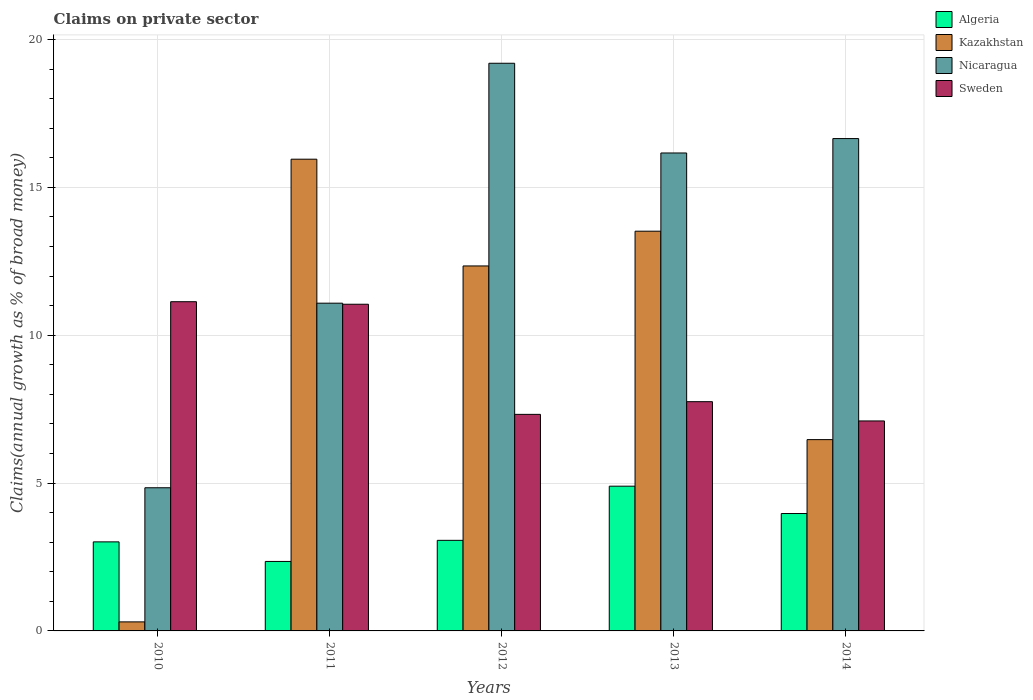How many groups of bars are there?
Make the answer very short. 5. Are the number of bars per tick equal to the number of legend labels?
Ensure brevity in your answer.  Yes. Are the number of bars on each tick of the X-axis equal?
Your response must be concise. Yes. How many bars are there on the 3rd tick from the left?
Your response must be concise. 4. What is the label of the 4th group of bars from the left?
Ensure brevity in your answer.  2013. In how many cases, is the number of bars for a given year not equal to the number of legend labels?
Your answer should be compact. 0. What is the percentage of broad money claimed on private sector in Sweden in 2010?
Offer a terse response. 11.13. Across all years, what is the maximum percentage of broad money claimed on private sector in Kazakhstan?
Provide a succinct answer. 15.95. Across all years, what is the minimum percentage of broad money claimed on private sector in Kazakhstan?
Give a very brief answer. 0.31. In which year was the percentage of broad money claimed on private sector in Algeria maximum?
Give a very brief answer. 2013. In which year was the percentage of broad money claimed on private sector in Algeria minimum?
Offer a terse response. 2011. What is the total percentage of broad money claimed on private sector in Sweden in the graph?
Your response must be concise. 44.35. What is the difference between the percentage of broad money claimed on private sector in Sweden in 2012 and that in 2014?
Your answer should be compact. 0.22. What is the difference between the percentage of broad money claimed on private sector in Algeria in 2010 and the percentage of broad money claimed on private sector in Nicaragua in 2014?
Your answer should be very brief. -13.64. What is the average percentage of broad money claimed on private sector in Sweden per year?
Keep it short and to the point. 8.87. In the year 2013, what is the difference between the percentage of broad money claimed on private sector in Algeria and percentage of broad money claimed on private sector in Nicaragua?
Your answer should be compact. -11.27. In how many years, is the percentage of broad money claimed on private sector in Nicaragua greater than 14 %?
Provide a succinct answer. 3. What is the ratio of the percentage of broad money claimed on private sector in Kazakhstan in 2012 to that in 2014?
Ensure brevity in your answer.  1.91. Is the percentage of broad money claimed on private sector in Sweden in 2010 less than that in 2013?
Your response must be concise. No. What is the difference between the highest and the second highest percentage of broad money claimed on private sector in Kazakhstan?
Offer a terse response. 2.43. What is the difference between the highest and the lowest percentage of broad money claimed on private sector in Sweden?
Your answer should be compact. 4.03. In how many years, is the percentage of broad money claimed on private sector in Kazakhstan greater than the average percentage of broad money claimed on private sector in Kazakhstan taken over all years?
Provide a succinct answer. 3. Is the sum of the percentage of broad money claimed on private sector in Sweden in 2011 and 2014 greater than the maximum percentage of broad money claimed on private sector in Algeria across all years?
Provide a short and direct response. Yes. Is it the case that in every year, the sum of the percentage of broad money claimed on private sector in Kazakhstan and percentage of broad money claimed on private sector in Sweden is greater than the sum of percentage of broad money claimed on private sector in Algeria and percentage of broad money claimed on private sector in Nicaragua?
Offer a terse response. No. What does the 3rd bar from the right in 2010 represents?
Offer a very short reply. Kazakhstan. Is it the case that in every year, the sum of the percentage of broad money claimed on private sector in Nicaragua and percentage of broad money claimed on private sector in Kazakhstan is greater than the percentage of broad money claimed on private sector in Sweden?
Provide a succinct answer. No. How many bars are there?
Give a very brief answer. 20. Are all the bars in the graph horizontal?
Keep it short and to the point. No. How are the legend labels stacked?
Offer a very short reply. Vertical. What is the title of the graph?
Offer a terse response. Claims on private sector. Does "Hong Kong" appear as one of the legend labels in the graph?
Ensure brevity in your answer.  No. What is the label or title of the Y-axis?
Give a very brief answer. Claims(annual growth as % of broad money). What is the Claims(annual growth as % of broad money) in Algeria in 2010?
Give a very brief answer. 3.01. What is the Claims(annual growth as % of broad money) of Kazakhstan in 2010?
Offer a very short reply. 0.31. What is the Claims(annual growth as % of broad money) of Nicaragua in 2010?
Offer a terse response. 4.84. What is the Claims(annual growth as % of broad money) of Sweden in 2010?
Keep it short and to the point. 11.13. What is the Claims(annual growth as % of broad money) of Algeria in 2011?
Your answer should be very brief. 2.35. What is the Claims(annual growth as % of broad money) in Kazakhstan in 2011?
Provide a short and direct response. 15.95. What is the Claims(annual growth as % of broad money) of Nicaragua in 2011?
Offer a very short reply. 11.08. What is the Claims(annual growth as % of broad money) of Sweden in 2011?
Your answer should be very brief. 11.05. What is the Claims(annual growth as % of broad money) of Algeria in 2012?
Your response must be concise. 3.06. What is the Claims(annual growth as % of broad money) in Kazakhstan in 2012?
Your response must be concise. 12.34. What is the Claims(annual growth as % of broad money) of Nicaragua in 2012?
Provide a succinct answer. 19.2. What is the Claims(annual growth as % of broad money) in Sweden in 2012?
Provide a short and direct response. 7.32. What is the Claims(annual growth as % of broad money) in Algeria in 2013?
Provide a short and direct response. 4.89. What is the Claims(annual growth as % of broad money) in Kazakhstan in 2013?
Keep it short and to the point. 13.52. What is the Claims(annual growth as % of broad money) of Nicaragua in 2013?
Offer a very short reply. 16.16. What is the Claims(annual growth as % of broad money) in Sweden in 2013?
Ensure brevity in your answer.  7.75. What is the Claims(annual growth as % of broad money) of Algeria in 2014?
Your answer should be very brief. 3.97. What is the Claims(annual growth as % of broad money) in Kazakhstan in 2014?
Your answer should be very brief. 6.47. What is the Claims(annual growth as % of broad money) in Nicaragua in 2014?
Your response must be concise. 16.65. What is the Claims(annual growth as % of broad money) in Sweden in 2014?
Offer a very short reply. 7.1. Across all years, what is the maximum Claims(annual growth as % of broad money) in Algeria?
Keep it short and to the point. 4.89. Across all years, what is the maximum Claims(annual growth as % of broad money) in Kazakhstan?
Provide a succinct answer. 15.95. Across all years, what is the maximum Claims(annual growth as % of broad money) in Nicaragua?
Provide a short and direct response. 19.2. Across all years, what is the maximum Claims(annual growth as % of broad money) of Sweden?
Offer a very short reply. 11.13. Across all years, what is the minimum Claims(annual growth as % of broad money) in Algeria?
Your response must be concise. 2.35. Across all years, what is the minimum Claims(annual growth as % of broad money) in Kazakhstan?
Your answer should be compact. 0.31. Across all years, what is the minimum Claims(annual growth as % of broad money) of Nicaragua?
Provide a succinct answer. 4.84. Across all years, what is the minimum Claims(annual growth as % of broad money) of Sweden?
Give a very brief answer. 7.1. What is the total Claims(annual growth as % of broad money) of Algeria in the graph?
Give a very brief answer. 17.29. What is the total Claims(annual growth as % of broad money) of Kazakhstan in the graph?
Offer a terse response. 48.58. What is the total Claims(annual growth as % of broad money) of Nicaragua in the graph?
Your answer should be compact. 67.93. What is the total Claims(annual growth as % of broad money) in Sweden in the graph?
Offer a terse response. 44.35. What is the difference between the Claims(annual growth as % of broad money) in Algeria in 2010 and that in 2011?
Ensure brevity in your answer.  0.66. What is the difference between the Claims(annual growth as % of broad money) in Kazakhstan in 2010 and that in 2011?
Keep it short and to the point. -15.65. What is the difference between the Claims(annual growth as % of broad money) in Nicaragua in 2010 and that in 2011?
Your response must be concise. -6.24. What is the difference between the Claims(annual growth as % of broad money) of Sweden in 2010 and that in 2011?
Your answer should be compact. 0.09. What is the difference between the Claims(annual growth as % of broad money) of Algeria in 2010 and that in 2012?
Provide a short and direct response. -0.05. What is the difference between the Claims(annual growth as % of broad money) of Kazakhstan in 2010 and that in 2012?
Keep it short and to the point. -12.04. What is the difference between the Claims(annual growth as % of broad money) in Nicaragua in 2010 and that in 2012?
Your answer should be compact. -14.35. What is the difference between the Claims(annual growth as % of broad money) of Sweden in 2010 and that in 2012?
Make the answer very short. 3.81. What is the difference between the Claims(annual growth as % of broad money) in Algeria in 2010 and that in 2013?
Your answer should be compact. -1.88. What is the difference between the Claims(annual growth as % of broad money) in Kazakhstan in 2010 and that in 2013?
Provide a short and direct response. -13.21. What is the difference between the Claims(annual growth as % of broad money) in Nicaragua in 2010 and that in 2013?
Your answer should be compact. -11.32. What is the difference between the Claims(annual growth as % of broad money) of Sweden in 2010 and that in 2013?
Provide a succinct answer. 3.38. What is the difference between the Claims(annual growth as % of broad money) in Algeria in 2010 and that in 2014?
Keep it short and to the point. -0.96. What is the difference between the Claims(annual growth as % of broad money) of Kazakhstan in 2010 and that in 2014?
Offer a terse response. -6.16. What is the difference between the Claims(annual growth as % of broad money) in Nicaragua in 2010 and that in 2014?
Provide a succinct answer. -11.81. What is the difference between the Claims(annual growth as % of broad money) of Sweden in 2010 and that in 2014?
Your answer should be compact. 4.03. What is the difference between the Claims(annual growth as % of broad money) in Algeria in 2011 and that in 2012?
Your answer should be compact. -0.71. What is the difference between the Claims(annual growth as % of broad money) of Kazakhstan in 2011 and that in 2012?
Provide a short and direct response. 3.61. What is the difference between the Claims(annual growth as % of broad money) of Nicaragua in 2011 and that in 2012?
Keep it short and to the point. -8.11. What is the difference between the Claims(annual growth as % of broad money) in Sweden in 2011 and that in 2012?
Offer a terse response. 3.72. What is the difference between the Claims(annual growth as % of broad money) of Algeria in 2011 and that in 2013?
Give a very brief answer. -2.55. What is the difference between the Claims(annual growth as % of broad money) of Kazakhstan in 2011 and that in 2013?
Give a very brief answer. 2.43. What is the difference between the Claims(annual growth as % of broad money) of Nicaragua in 2011 and that in 2013?
Offer a very short reply. -5.08. What is the difference between the Claims(annual growth as % of broad money) of Sweden in 2011 and that in 2013?
Your answer should be very brief. 3.29. What is the difference between the Claims(annual growth as % of broad money) of Algeria in 2011 and that in 2014?
Provide a short and direct response. -1.62. What is the difference between the Claims(annual growth as % of broad money) in Kazakhstan in 2011 and that in 2014?
Ensure brevity in your answer.  9.48. What is the difference between the Claims(annual growth as % of broad money) of Nicaragua in 2011 and that in 2014?
Ensure brevity in your answer.  -5.57. What is the difference between the Claims(annual growth as % of broad money) in Sweden in 2011 and that in 2014?
Give a very brief answer. 3.95. What is the difference between the Claims(annual growth as % of broad money) in Algeria in 2012 and that in 2013?
Provide a succinct answer. -1.83. What is the difference between the Claims(annual growth as % of broad money) in Kazakhstan in 2012 and that in 2013?
Your answer should be compact. -1.17. What is the difference between the Claims(annual growth as % of broad money) in Nicaragua in 2012 and that in 2013?
Provide a succinct answer. 3.03. What is the difference between the Claims(annual growth as % of broad money) of Sweden in 2012 and that in 2013?
Provide a short and direct response. -0.43. What is the difference between the Claims(annual growth as % of broad money) in Algeria in 2012 and that in 2014?
Give a very brief answer. -0.91. What is the difference between the Claims(annual growth as % of broad money) in Kazakhstan in 2012 and that in 2014?
Your answer should be compact. 5.87. What is the difference between the Claims(annual growth as % of broad money) of Nicaragua in 2012 and that in 2014?
Your answer should be very brief. 2.55. What is the difference between the Claims(annual growth as % of broad money) in Sweden in 2012 and that in 2014?
Make the answer very short. 0.22. What is the difference between the Claims(annual growth as % of broad money) in Algeria in 2013 and that in 2014?
Offer a terse response. 0.92. What is the difference between the Claims(annual growth as % of broad money) of Kazakhstan in 2013 and that in 2014?
Offer a very short reply. 7.05. What is the difference between the Claims(annual growth as % of broad money) in Nicaragua in 2013 and that in 2014?
Make the answer very short. -0.49. What is the difference between the Claims(annual growth as % of broad money) of Sweden in 2013 and that in 2014?
Your response must be concise. 0.65. What is the difference between the Claims(annual growth as % of broad money) in Algeria in 2010 and the Claims(annual growth as % of broad money) in Kazakhstan in 2011?
Your answer should be compact. -12.94. What is the difference between the Claims(annual growth as % of broad money) of Algeria in 2010 and the Claims(annual growth as % of broad money) of Nicaragua in 2011?
Your answer should be very brief. -8.07. What is the difference between the Claims(annual growth as % of broad money) in Algeria in 2010 and the Claims(annual growth as % of broad money) in Sweden in 2011?
Make the answer very short. -8.04. What is the difference between the Claims(annual growth as % of broad money) of Kazakhstan in 2010 and the Claims(annual growth as % of broad money) of Nicaragua in 2011?
Ensure brevity in your answer.  -10.78. What is the difference between the Claims(annual growth as % of broad money) of Kazakhstan in 2010 and the Claims(annual growth as % of broad money) of Sweden in 2011?
Your answer should be compact. -10.74. What is the difference between the Claims(annual growth as % of broad money) in Nicaragua in 2010 and the Claims(annual growth as % of broad money) in Sweden in 2011?
Give a very brief answer. -6.21. What is the difference between the Claims(annual growth as % of broad money) in Algeria in 2010 and the Claims(annual growth as % of broad money) in Kazakhstan in 2012?
Your response must be concise. -9.33. What is the difference between the Claims(annual growth as % of broad money) in Algeria in 2010 and the Claims(annual growth as % of broad money) in Nicaragua in 2012?
Give a very brief answer. -16.18. What is the difference between the Claims(annual growth as % of broad money) of Algeria in 2010 and the Claims(annual growth as % of broad money) of Sweden in 2012?
Your answer should be compact. -4.31. What is the difference between the Claims(annual growth as % of broad money) of Kazakhstan in 2010 and the Claims(annual growth as % of broad money) of Nicaragua in 2012?
Make the answer very short. -18.89. What is the difference between the Claims(annual growth as % of broad money) of Kazakhstan in 2010 and the Claims(annual growth as % of broad money) of Sweden in 2012?
Provide a succinct answer. -7.02. What is the difference between the Claims(annual growth as % of broad money) in Nicaragua in 2010 and the Claims(annual growth as % of broad money) in Sweden in 2012?
Provide a short and direct response. -2.48. What is the difference between the Claims(annual growth as % of broad money) in Algeria in 2010 and the Claims(annual growth as % of broad money) in Kazakhstan in 2013?
Offer a very short reply. -10.51. What is the difference between the Claims(annual growth as % of broad money) in Algeria in 2010 and the Claims(annual growth as % of broad money) in Nicaragua in 2013?
Your answer should be compact. -13.15. What is the difference between the Claims(annual growth as % of broad money) in Algeria in 2010 and the Claims(annual growth as % of broad money) in Sweden in 2013?
Provide a succinct answer. -4.74. What is the difference between the Claims(annual growth as % of broad money) of Kazakhstan in 2010 and the Claims(annual growth as % of broad money) of Nicaragua in 2013?
Your answer should be compact. -15.86. What is the difference between the Claims(annual growth as % of broad money) of Kazakhstan in 2010 and the Claims(annual growth as % of broad money) of Sweden in 2013?
Make the answer very short. -7.45. What is the difference between the Claims(annual growth as % of broad money) of Nicaragua in 2010 and the Claims(annual growth as % of broad money) of Sweden in 2013?
Your answer should be very brief. -2.91. What is the difference between the Claims(annual growth as % of broad money) of Algeria in 2010 and the Claims(annual growth as % of broad money) of Kazakhstan in 2014?
Your answer should be compact. -3.46. What is the difference between the Claims(annual growth as % of broad money) of Algeria in 2010 and the Claims(annual growth as % of broad money) of Nicaragua in 2014?
Make the answer very short. -13.64. What is the difference between the Claims(annual growth as % of broad money) in Algeria in 2010 and the Claims(annual growth as % of broad money) in Sweden in 2014?
Your answer should be very brief. -4.09. What is the difference between the Claims(annual growth as % of broad money) in Kazakhstan in 2010 and the Claims(annual growth as % of broad money) in Nicaragua in 2014?
Make the answer very short. -16.34. What is the difference between the Claims(annual growth as % of broad money) of Kazakhstan in 2010 and the Claims(annual growth as % of broad money) of Sweden in 2014?
Keep it short and to the point. -6.79. What is the difference between the Claims(annual growth as % of broad money) of Nicaragua in 2010 and the Claims(annual growth as % of broad money) of Sweden in 2014?
Keep it short and to the point. -2.26. What is the difference between the Claims(annual growth as % of broad money) in Algeria in 2011 and the Claims(annual growth as % of broad money) in Kazakhstan in 2012?
Offer a terse response. -9.99. What is the difference between the Claims(annual growth as % of broad money) in Algeria in 2011 and the Claims(annual growth as % of broad money) in Nicaragua in 2012?
Provide a short and direct response. -16.85. What is the difference between the Claims(annual growth as % of broad money) of Algeria in 2011 and the Claims(annual growth as % of broad money) of Sweden in 2012?
Your answer should be very brief. -4.97. What is the difference between the Claims(annual growth as % of broad money) in Kazakhstan in 2011 and the Claims(annual growth as % of broad money) in Nicaragua in 2012?
Give a very brief answer. -3.24. What is the difference between the Claims(annual growth as % of broad money) in Kazakhstan in 2011 and the Claims(annual growth as % of broad money) in Sweden in 2012?
Ensure brevity in your answer.  8.63. What is the difference between the Claims(annual growth as % of broad money) in Nicaragua in 2011 and the Claims(annual growth as % of broad money) in Sweden in 2012?
Keep it short and to the point. 3.76. What is the difference between the Claims(annual growth as % of broad money) of Algeria in 2011 and the Claims(annual growth as % of broad money) of Kazakhstan in 2013?
Give a very brief answer. -11.17. What is the difference between the Claims(annual growth as % of broad money) of Algeria in 2011 and the Claims(annual growth as % of broad money) of Nicaragua in 2013?
Offer a terse response. -13.81. What is the difference between the Claims(annual growth as % of broad money) of Algeria in 2011 and the Claims(annual growth as % of broad money) of Sweden in 2013?
Your response must be concise. -5.4. What is the difference between the Claims(annual growth as % of broad money) in Kazakhstan in 2011 and the Claims(annual growth as % of broad money) in Nicaragua in 2013?
Make the answer very short. -0.21. What is the difference between the Claims(annual growth as % of broad money) of Kazakhstan in 2011 and the Claims(annual growth as % of broad money) of Sweden in 2013?
Make the answer very short. 8.2. What is the difference between the Claims(annual growth as % of broad money) of Nicaragua in 2011 and the Claims(annual growth as % of broad money) of Sweden in 2013?
Keep it short and to the point. 3.33. What is the difference between the Claims(annual growth as % of broad money) in Algeria in 2011 and the Claims(annual growth as % of broad money) in Kazakhstan in 2014?
Provide a succinct answer. -4.12. What is the difference between the Claims(annual growth as % of broad money) in Algeria in 2011 and the Claims(annual growth as % of broad money) in Nicaragua in 2014?
Your response must be concise. -14.3. What is the difference between the Claims(annual growth as % of broad money) of Algeria in 2011 and the Claims(annual growth as % of broad money) of Sweden in 2014?
Offer a terse response. -4.75. What is the difference between the Claims(annual growth as % of broad money) in Kazakhstan in 2011 and the Claims(annual growth as % of broad money) in Nicaragua in 2014?
Your response must be concise. -0.7. What is the difference between the Claims(annual growth as % of broad money) of Kazakhstan in 2011 and the Claims(annual growth as % of broad money) of Sweden in 2014?
Give a very brief answer. 8.85. What is the difference between the Claims(annual growth as % of broad money) in Nicaragua in 2011 and the Claims(annual growth as % of broad money) in Sweden in 2014?
Offer a very short reply. 3.98. What is the difference between the Claims(annual growth as % of broad money) of Algeria in 2012 and the Claims(annual growth as % of broad money) of Kazakhstan in 2013?
Give a very brief answer. -10.45. What is the difference between the Claims(annual growth as % of broad money) in Algeria in 2012 and the Claims(annual growth as % of broad money) in Nicaragua in 2013?
Make the answer very short. -13.1. What is the difference between the Claims(annual growth as % of broad money) of Algeria in 2012 and the Claims(annual growth as % of broad money) of Sweden in 2013?
Offer a very short reply. -4.69. What is the difference between the Claims(annual growth as % of broad money) in Kazakhstan in 2012 and the Claims(annual growth as % of broad money) in Nicaragua in 2013?
Give a very brief answer. -3.82. What is the difference between the Claims(annual growth as % of broad money) of Kazakhstan in 2012 and the Claims(annual growth as % of broad money) of Sweden in 2013?
Offer a terse response. 4.59. What is the difference between the Claims(annual growth as % of broad money) of Nicaragua in 2012 and the Claims(annual growth as % of broad money) of Sweden in 2013?
Your answer should be very brief. 11.44. What is the difference between the Claims(annual growth as % of broad money) of Algeria in 2012 and the Claims(annual growth as % of broad money) of Kazakhstan in 2014?
Ensure brevity in your answer.  -3.41. What is the difference between the Claims(annual growth as % of broad money) of Algeria in 2012 and the Claims(annual growth as % of broad money) of Nicaragua in 2014?
Your response must be concise. -13.59. What is the difference between the Claims(annual growth as % of broad money) in Algeria in 2012 and the Claims(annual growth as % of broad money) in Sweden in 2014?
Ensure brevity in your answer.  -4.04. What is the difference between the Claims(annual growth as % of broad money) in Kazakhstan in 2012 and the Claims(annual growth as % of broad money) in Nicaragua in 2014?
Your answer should be very brief. -4.31. What is the difference between the Claims(annual growth as % of broad money) in Kazakhstan in 2012 and the Claims(annual growth as % of broad money) in Sweden in 2014?
Give a very brief answer. 5.24. What is the difference between the Claims(annual growth as % of broad money) of Nicaragua in 2012 and the Claims(annual growth as % of broad money) of Sweden in 2014?
Your answer should be very brief. 12.1. What is the difference between the Claims(annual growth as % of broad money) in Algeria in 2013 and the Claims(annual growth as % of broad money) in Kazakhstan in 2014?
Provide a succinct answer. -1.57. What is the difference between the Claims(annual growth as % of broad money) of Algeria in 2013 and the Claims(annual growth as % of broad money) of Nicaragua in 2014?
Your answer should be compact. -11.75. What is the difference between the Claims(annual growth as % of broad money) of Algeria in 2013 and the Claims(annual growth as % of broad money) of Sweden in 2014?
Offer a terse response. -2.21. What is the difference between the Claims(annual growth as % of broad money) in Kazakhstan in 2013 and the Claims(annual growth as % of broad money) in Nicaragua in 2014?
Give a very brief answer. -3.13. What is the difference between the Claims(annual growth as % of broad money) in Kazakhstan in 2013 and the Claims(annual growth as % of broad money) in Sweden in 2014?
Provide a short and direct response. 6.42. What is the difference between the Claims(annual growth as % of broad money) of Nicaragua in 2013 and the Claims(annual growth as % of broad money) of Sweden in 2014?
Give a very brief answer. 9.06. What is the average Claims(annual growth as % of broad money) in Algeria per year?
Provide a succinct answer. 3.46. What is the average Claims(annual growth as % of broad money) of Kazakhstan per year?
Make the answer very short. 9.72. What is the average Claims(annual growth as % of broad money) in Nicaragua per year?
Provide a short and direct response. 13.59. What is the average Claims(annual growth as % of broad money) of Sweden per year?
Make the answer very short. 8.87. In the year 2010, what is the difference between the Claims(annual growth as % of broad money) in Algeria and Claims(annual growth as % of broad money) in Kazakhstan?
Offer a very short reply. 2.71. In the year 2010, what is the difference between the Claims(annual growth as % of broad money) in Algeria and Claims(annual growth as % of broad money) in Nicaragua?
Provide a short and direct response. -1.83. In the year 2010, what is the difference between the Claims(annual growth as % of broad money) in Algeria and Claims(annual growth as % of broad money) in Sweden?
Your answer should be compact. -8.12. In the year 2010, what is the difference between the Claims(annual growth as % of broad money) of Kazakhstan and Claims(annual growth as % of broad money) of Nicaragua?
Provide a succinct answer. -4.54. In the year 2010, what is the difference between the Claims(annual growth as % of broad money) of Kazakhstan and Claims(annual growth as % of broad money) of Sweden?
Provide a short and direct response. -10.83. In the year 2010, what is the difference between the Claims(annual growth as % of broad money) of Nicaragua and Claims(annual growth as % of broad money) of Sweden?
Provide a short and direct response. -6.29. In the year 2011, what is the difference between the Claims(annual growth as % of broad money) of Algeria and Claims(annual growth as % of broad money) of Kazakhstan?
Give a very brief answer. -13.6. In the year 2011, what is the difference between the Claims(annual growth as % of broad money) of Algeria and Claims(annual growth as % of broad money) of Nicaragua?
Offer a very short reply. -8.73. In the year 2011, what is the difference between the Claims(annual growth as % of broad money) of Algeria and Claims(annual growth as % of broad money) of Sweden?
Provide a short and direct response. -8.7. In the year 2011, what is the difference between the Claims(annual growth as % of broad money) in Kazakhstan and Claims(annual growth as % of broad money) in Nicaragua?
Your response must be concise. 4.87. In the year 2011, what is the difference between the Claims(annual growth as % of broad money) in Kazakhstan and Claims(annual growth as % of broad money) in Sweden?
Offer a terse response. 4.9. In the year 2011, what is the difference between the Claims(annual growth as % of broad money) of Nicaragua and Claims(annual growth as % of broad money) of Sweden?
Your answer should be very brief. 0.04. In the year 2012, what is the difference between the Claims(annual growth as % of broad money) in Algeria and Claims(annual growth as % of broad money) in Kazakhstan?
Provide a succinct answer. -9.28. In the year 2012, what is the difference between the Claims(annual growth as % of broad money) of Algeria and Claims(annual growth as % of broad money) of Nicaragua?
Your answer should be very brief. -16.13. In the year 2012, what is the difference between the Claims(annual growth as % of broad money) in Algeria and Claims(annual growth as % of broad money) in Sweden?
Give a very brief answer. -4.26. In the year 2012, what is the difference between the Claims(annual growth as % of broad money) of Kazakhstan and Claims(annual growth as % of broad money) of Nicaragua?
Your answer should be very brief. -6.85. In the year 2012, what is the difference between the Claims(annual growth as % of broad money) in Kazakhstan and Claims(annual growth as % of broad money) in Sweden?
Ensure brevity in your answer.  5.02. In the year 2012, what is the difference between the Claims(annual growth as % of broad money) in Nicaragua and Claims(annual growth as % of broad money) in Sweden?
Ensure brevity in your answer.  11.87. In the year 2013, what is the difference between the Claims(annual growth as % of broad money) of Algeria and Claims(annual growth as % of broad money) of Kazakhstan?
Provide a succinct answer. -8.62. In the year 2013, what is the difference between the Claims(annual growth as % of broad money) in Algeria and Claims(annual growth as % of broad money) in Nicaragua?
Offer a terse response. -11.27. In the year 2013, what is the difference between the Claims(annual growth as % of broad money) in Algeria and Claims(annual growth as % of broad money) in Sweden?
Ensure brevity in your answer.  -2.86. In the year 2013, what is the difference between the Claims(annual growth as % of broad money) in Kazakhstan and Claims(annual growth as % of broad money) in Nicaragua?
Your answer should be compact. -2.65. In the year 2013, what is the difference between the Claims(annual growth as % of broad money) of Kazakhstan and Claims(annual growth as % of broad money) of Sweden?
Your answer should be compact. 5.76. In the year 2013, what is the difference between the Claims(annual growth as % of broad money) in Nicaragua and Claims(annual growth as % of broad money) in Sweden?
Your answer should be very brief. 8.41. In the year 2014, what is the difference between the Claims(annual growth as % of broad money) of Algeria and Claims(annual growth as % of broad money) of Kazakhstan?
Offer a very short reply. -2.5. In the year 2014, what is the difference between the Claims(annual growth as % of broad money) in Algeria and Claims(annual growth as % of broad money) in Nicaragua?
Provide a short and direct response. -12.68. In the year 2014, what is the difference between the Claims(annual growth as % of broad money) of Algeria and Claims(annual growth as % of broad money) of Sweden?
Your response must be concise. -3.13. In the year 2014, what is the difference between the Claims(annual growth as % of broad money) in Kazakhstan and Claims(annual growth as % of broad money) in Nicaragua?
Keep it short and to the point. -10.18. In the year 2014, what is the difference between the Claims(annual growth as % of broad money) of Kazakhstan and Claims(annual growth as % of broad money) of Sweden?
Provide a succinct answer. -0.63. In the year 2014, what is the difference between the Claims(annual growth as % of broad money) of Nicaragua and Claims(annual growth as % of broad money) of Sweden?
Keep it short and to the point. 9.55. What is the ratio of the Claims(annual growth as % of broad money) in Algeria in 2010 to that in 2011?
Keep it short and to the point. 1.28. What is the ratio of the Claims(annual growth as % of broad money) in Kazakhstan in 2010 to that in 2011?
Make the answer very short. 0.02. What is the ratio of the Claims(annual growth as % of broad money) of Nicaragua in 2010 to that in 2011?
Provide a succinct answer. 0.44. What is the ratio of the Claims(annual growth as % of broad money) in Sweden in 2010 to that in 2011?
Your answer should be very brief. 1.01. What is the ratio of the Claims(annual growth as % of broad money) in Algeria in 2010 to that in 2012?
Your answer should be compact. 0.98. What is the ratio of the Claims(annual growth as % of broad money) of Kazakhstan in 2010 to that in 2012?
Provide a short and direct response. 0.02. What is the ratio of the Claims(annual growth as % of broad money) in Nicaragua in 2010 to that in 2012?
Offer a very short reply. 0.25. What is the ratio of the Claims(annual growth as % of broad money) of Sweden in 2010 to that in 2012?
Provide a succinct answer. 1.52. What is the ratio of the Claims(annual growth as % of broad money) in Algeria in 2010 to that in 2013?
Provide a succinct answer. 0.62. What is the ratio of the Claims(annual growth as % of broad money) in Kazakhstan in 2010 to that in 2013?
Offer a terse response. 0.02. What is the ratio of the Claims(annual growth as % of broad money) in Nicaragua in 2010 to that in 2013?
Make the answer very short. 0.3. What is the ratio of the Claims(annual growth as % of broad money) in Sweden in 2010 to that in 2013?
Provide a succinct answer. 1.44. What is the ratio of the Claims(annual growth as % of broad money) of Algeria in 2010 to that in 2014?
Your answer should be compact. 0.76. What is the ratio of the Claims(annual growth as % of broad money) of Kazakhstan in 2010 to that in 2014?
Your response must be concise. 0.05. What is the ratio of the Claims(annual growth as % of broad money) of Nicaragua in 2010 to that in 2014?
Your answer should be compact. 0.29. What is the ratio of the Claims(annual growth as % of broad money) of Sweden in 2010 to that in 2014?
Keep it short and to the point. 1.57. What is the ratio of the Claims(annual growth as % of broad money) in Algeria in 2011 to that in 2012?
Provide a succinct answer. 0.77. What is the ratio of the Claims(annual growth as % of broad money) in Kazakhstan in 2011 to that in 2012?
Your answer should be compact. 1.29. What is the ratio of the Claims(annual growth as % of broad money) in Nicaragua in 2011 to that in 2012?
Offer a very short reply. 0.58. What is the ratio of the Claims(annual growth as % of broad money) in Sweden in 2011 to that in 2012?
Provide a short and direct response. 1.51. What is the ratio of the Claims(annual growth as % of broad money) of Algeria in 2011 to that in 2013?
Offer a very short reply. 0.48. What is the ratio of the Claims(annual growth as % of broad money) in Kazakhstan in 2011 to that in 2013?
Offer a very short reply. 1.18. What is the ratio of the Claims(annual growth as % of broad money) in Nicaragua in 2011 to that in 2013?
Provide a succinct answer. 0.69. What is the ratio of the Claims(annual growth as % of broad money) of Sweden in 2011 to that in 2013?
Give a very brief answer. 1.43. What is the ratio of the Claims(annual growth as % of broad money) in Algeria in 2011 to that in 2014?
Provide a short and direct response. 0.59. What is the ratio of the Claims(annual growth as % of broad money) in Kazakhstan in 2011 to that in 2014?
Give a very brief answer. 2.47. What is the ratio of the Claims(annual growth as % of broad money) in Nicaragua in 2011 to that in 2014?
Your answer should be very brief. 0.67. What is the ratio of the Claims(annual growth as % of broad money) of Sweden in 2011 to that in 2014?
Provide a succinct answer. 1.56. What is the ratio of the Claims(annual growth as % of broad money) of Algeria in 2012 to that in 2013?
Offer a terse response. 0.63. What is the ratio of the Claims(annual growth as % of broad money) in Kazakhstan in 2012 to that in 2013?
Your answer should be very brief. 0.91. What is the ratio of the Claims(annual growth as % of broad money) in Nicaragua in 2012 to that in 2013?
Your answer should be compact. 1.19. What is the ratio of the Claims(annual growth as % of broad money) in Sweden in 2012 to that in 2013?
Keep it short and to the point. 0.94. What is the ratio of the Claims(annual growth as % of broad money) of Algeria in 2012 to that in 2014?
Offer a terse response. 0.77. What is the ratio of the Claims(annual growth as % of broad money) in Kazakhstan in 2012 to that in 2014?
Your answer should be very brief. 1.91. What is the ratio of the Claims(annual growth as % of broad money) in Nicaragua in 2012 to that in 2014?
Your answer should be compact. 1.15. What is the ratio of the Claims(annual growth as % of broad money) in Sweden in 2012 to that in 2014?
Offer a very short reply. 1.03. What is the ratio of the Claims(annual growth as % of broad money) in Algeria in 2013 to that in 2014?
Your answer should be very brief. 1.23. What is the ratio of the Claims(annual growth as % of broad money) of Kazakhstan in 2013 to that in 2014?
Keep it short and to the point. 2.09. What is the ratio of the Claims(annual growth as % of broad money) of Nicaragua in 2013 to that in 2014?
Keep it short and to the point. 0.97. What is the ratio of the Claims(annual growth as % of broad money) of Sweden in 2013 to that in 2014?
Provide a succinct answer. 1.09. What is the difference between the highest and the second highest Claims(annual growth as % of broad money) in Algeria?
Your answer should be compact. 0.92. What is the difference between the highest and the second highest Claims(annual growth as % of broad money) of Kazakhstan?
Make the answer very short. 2.43. What is the difference between the highest and the second highest Claims(annual growth as % of broad money) in Nicaragua?
Ensure brevity in your answer.  2.55. What is the difference between the highest and the second highest Claims(annual growth as % of broad money) of Sweden?
Offer a very short reply. 0.09. What is the difference between the highest and the lowest Claims(annual growth as % of broad money) in Algeria?
Provide a succinct answer. 2.55. What is the difference between the highest and the lowest Claims(annual growth as % of broad money) in Kazakhstan?
Give a very brief answer. 15.65. What is the difference between the highest and the lowest Claims(annual growth as % of broad money) in Nicaragua?
Provide a short and direct response. 14.35. What is the difference between the highest and the lowest Claims(annual growth as % of broad money) in Sweden?
Your response must be concise. 4.03. 